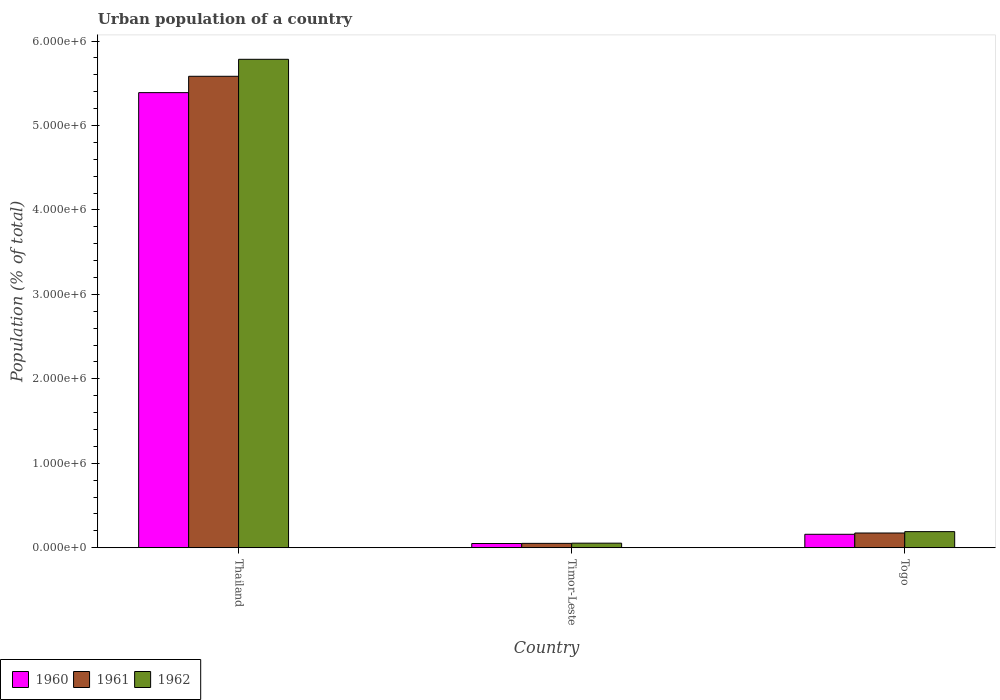How many different coloured bars are there?
Your answer should be compact. 3. How many bars are there on the 2nd tick from the right?
Keep it short and to the point. 3. What is the label of the 1st group of bars from the left?
Your answer should be very brief. Thailand. What is the urban population in 1961 in Timor-Leste?
Offer a very short reply. 5.21e+04. Across all countries, what is the maximum urban population in 1961?
Offer a terse response. 5.58e+06. Across all countries, what is the minimum urban population in 1962?
Your answer should be very brief. 5.44e+04. In which country was the urban population in 1961 maximum?
Make the answer very short. Thailand. In which country was the urban population in 1962 minimum?
Your answer should be compact. Timor-Leste. What is the total urban population in 1960 in the graph?
Offer a very short reply. 5.60e+06. What is the difference between the urban population in 1961 in Timor-Leste and that in Togo?
Offer a very short reply. -1.23e+05. What is the difference between the urban population in 1960 in Timor-Leste and the urban population in 1962 in Togo?
Offer a terse response. -1.41e+05. What is the average urban population in 1962 per country?
Ensure brevity in your answer.  2.01e+06. What is the difference between the urban population of/in 1960 and urban population of/in 1961 in Timor-Leste?
Ensure brevity in your answer.  -1659. What is the ratio of the urban population in 1960 in Thailand to that in Togo?
Offer a terse response. 33.77. Is the urban population in 1961 in Timor-Leste less than that in Togo?
Make the answer very short. Yes. Is the difference between the urban population in 1960 in Thailand and Togo greater than the difference between the urban population in 1961 in Thailand and Togo?
Your response must be concise. No. What is the difference between the highest and the second highest urban population in 1962?
Offer a terse response. 5.73e+06. What is the difference between the highest and the lowest urban population in 1961?
Your answer should be very brief. 5.53e+06. In how many countries, is the urban population in 1961 greater than the average urban population in 1961 taken over all countries?
Make the answer very short. 1. Is the sum of the urban population in 1962 in Thailand and Togo greater than the maximum urban population in 1961 across all countries?
Provide a short and direct response. Yes. What does the 1st bar from the left in Timor-Leste represents?
Provide a succinct answer. 1960. Are all the bars in the graph horizontal?
Provide a short and direct response. No. Does the graph contain any zero values?
Your answer should be very brief. No. How many legend labels are there?
Your answer should be very brief. 3. What is the title of the graph?
Make the answer very short. Urban population of a country. Does "1967" appear as one of the legend labels in the graph?
Your answer should be very brief. No. What is the label or title of the X-axis?
Make the answer very short. Country. What is the label or title of the Y-axis?
Provide a short and direct response. Population (% of total). What is the Population (% of total) in 1960 in Thailand?
Provide a short and direct response. 5.39e+06. What is the Population (% of total) of 1961 in Thailand?
Provide a short and direct response. 5.58e+06. What is the Population (% of total) of 1962 in Thailand?
Provide a short and direct response. 5.78e+06. What is the Population (% of total) of 1960 in Timor-Leste?
Offer a terse response. 5.04e+04. What is the Population (% of total) in 1961 in Timor-Leste?
Keep it short and to the point. 5.21e+04. What is the Population (% of total) of 1962 in Timor-Leste?
Make the answer very short. 5.44e+04. What is the Population (% of total) of 1960 in Togo?
Provide a short and direct response. 1.60e+05. What is the Population (% of total) in 1961 in Togo?
Give a very brief answer. 1.75e+05. What is the Population (% of total) in 1962 in Togo?
Your answer should be very brief. 1.91e+05. Across all countries, what is the maximum Population (% of total) of 1960?
Keep it short and to the point. 5.39e+06. Across all countries, what is the maximum Population (% of total) of 1961?
Make the answer very short. 5.58e+06. Across all countries, what is the maximum Population (% of total) of 1962?
Give a very brief answer. 5.78e+06. Across all countries, what is the minimum Population (% of total) of 1960?
Your response must be concise. 5.04e+04. Across all countries, what is the minimum Population (% of total) of 1961?
Your answer should be very brief. 5.21e+04. Across all countries, what is the minimum Population (% of total) in 1962?
Offer a terse response. 5.44e+04. What is the total Population (% of total) in 1960 in the graph?
Make the answer very short. 5.60e+06. What is the total Population (% of total) of 1961 in the graph?
Your answer should be very brief. 5.81e+06. What is the total Population (% of total) in 1962 in the graph?
Your answer should be compact. 6.03e+06. What is the difference between the Population (% of total) of 1960 in Thailand and that in Timor-Leste?
Provide a succinct answer. 5.34e+06. What is the difference between the Population (% of total) of 1961 in Thailand and that in Timor-Leste?
Provide a succinct answer. 5.53e+06. What is the difference between the Population (% of total) of 1962 in Thailand and that in Timor-Leste?
Your answer should be compact. 5.73e+06. What is the difference between the Population (% of total) of 1960 in Thailand and that in Togo?
Keep it short and to the point. 5.23e+06. What is the difference between the Population (% of total) in 1961 in Thailand and that in Togo?
Ensure brevity in your answer.  5.41e+06. What is the difference between the Population (% of total) of 1962 in Thailand and that in Togo?
Give a very brief answer. 5.59e+06. What is the difference between the Population (% of total) of 1960 in Timor-Leste and that in Togo?
Your answer should be compact. -1.09e+05. What is the difference between the Population (% of total) of 1961 in Timor-Leste and that in Togo?
Ensure brevity in your answer.  -1.23e+05. What is the difference between the Population (% of total) of 1962 in Timor-Leste and that in Togo?
Give a very brief answer. -1.37e+05. What is the difference between the Population (% of total) of 1960 in Thailand and the Population (% of total) of 1961 in Timor-Leste?
Give a very brief answer. 5.34e+06. What is the difference between the Population (% of total) in 1960 in Thailand and the Population (% of total) in 1962 in Timor-Leste?
Keep it short and to the point. 5.34e+06. What is the difference between the Population (% of total) in 1961 in Thailand and the Population (% of total) in 1962 in Timor-Leste?
Your response must be concise. 5.53e+06. What is the difference between the Population (% of total) in 1960 in Thailand and the Population (% of total) in 1961 in Togo?
Offer a very short reply. 5.21e+06. What is the difference between the Population (% of total) in 1960 in Thailand and the Population (% of total) in 1962 in Togo?
Ensure brevity in your answer.  5.20e+06. What is the difference between the Population (% of total) of 1961 in Thailand and the Population (% of total) of 1962 in Togo?
Your answer should be compact. 5.39e+06. What is the difference between the Population (% of total) of 1960 in Timor-Leste and the Population (% of total) of 1961 in Togo?
Your answer should be compact. -1.24e+05. What is the difference between the Population (% of total) of 1960 in Timor-Leste and the Population (% of total) of 1962 in Togo?
Ensure brevity in your answer.  -1.41e+05. What is the difference between the Population (% of total) of 1961 in Timor-Leste and the Population (% of total) of 1962 in Togo?
Your answer should be very brief. -1.39e+05. What is the average Population (% of total) of 1960 per country?
Ensure brevity in your answer.  1.87e+06. What is the average Population (% of total) of 1961 per country?
Offer a terse response. 1.94e+06. What is the average Population (% of total) of 1962 per country?
Your response must be concise. 2.01e+06. What is the difference between the Population (% of total) in 1960 and Population (% of total) in 1961 in Thailand?
Give a very brief answer. -1.93e+05. What is the difference between the Population (% of total) in 1960 and Population (% of total) in 1962 in Thailand?
Offer a terse response. -3.95e+05. What is the difference between the Population (% of total) in 1961 and Population (% of total) in 1962 in Thailand?
Your response must be concise. -2.01e+05. What is the difference between the Population (% of total) of 1960 and Population (% of total) of 1961 in Timor-Leste?
Your answer should be very brief. -1659. What is the difference between the Population (% of total) of 1960 and Population (% of total) of 1962 in Timor-Leste?
Keep it short and to the point. -3982. What is the difference between the Population (% of total) of 1961 and Population (% of total) of 1962 in Timor-Leste?
Provide a short and direct response. -2323. What is the difference between the Population (% of total) in 1960 and Population (% of total) in 1961 in Togo?
Give a very brief answer. -1.52e+04. What is the difference between the Population (% of total) in 1960 and Population (% of total) in 1962 in Togo?
Give a very brief answer. -3.14e+04. What is the difference between the Population (% of total) of 1961 and Population (% of total) of 1962 in Togo?
Provide a short and direct response. -1.62e+04. What is the ratio of the Population (% of total) in 1960 in Thailand to that in Timor-Leste?
Offer a terse response. 106.92. What is the ratio of the Population (% of total) of 1961 in Thailand to that in Timor-Leste?
Your answer should be compact. 107.23. What is the ratio of the Population (% of total) of 1962 in Thailand to that in Timor-Leste?
Provide a succinct answer. 106.35. What is the ratio of the Population (% of total) in 1960 in Thailand to that in Togo?
Give a very brief answer. 33.77. What is the ratio of the Population (% of total) of 1961 in Thailand to that in Togo?
Your response must be concise. 31.95. What is the ratio of the Population (% of total) in 1962 in Thailand to that in Togo?
Ensure brevity in your answer.  30.28. What is the ratio of the Population (% of total) of 1960 in Timor-Leste to that in Togo?
Ensure brevity in your answer.  0.32. What is the ratio of the Population (% of total) of 1961 in Timor-Leste to that in Togo?
Offer a terse response. 0.3. What is the ratio of the Population (% of total) in 1962 in Timor-Leste to that in Togo?
Ensure brevity in your answer.  0.28. What is the difference between the highest and the second highest Population (% of total) of 1960?
Provide a short and direct response. 5.23e+06. What is the difference between the highest and the second highest Population (% of total) in 1961?
Make the answer very short. 5.41e+06. What is the difference between the highest and the second highest Population (% of total) in 1962?
Your answer should be compact. 5.59e+06. What is the difference between the highest and the lowest Population (% of total) in 1960?
Make the answer very short. 5.34e+06. What is the difference between the highest and the lowest Population (% of total) of 1961?
Your answer should be compact. 5.53e+06. What is the difference between the highest and the lowest Population (% of total) in 1962?
Offer a terse response. 5.73e+06. 